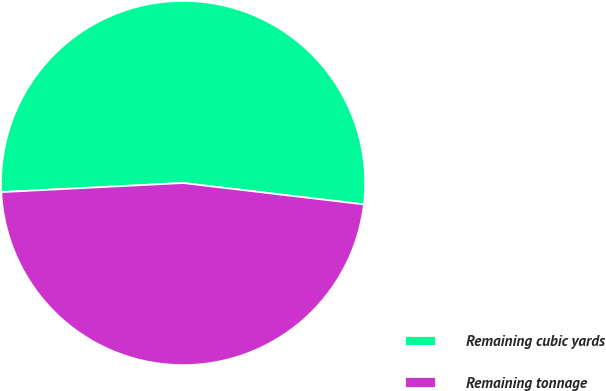Convert chart to OTSL. <chart><loc_0><loc_0><loc_500><loc_500><pie_chart><fcel>Remaining cubic yards<fcel>Remaining tonnage<nl><fcel>52.67%<fcel>47.33%<nl></chart> 